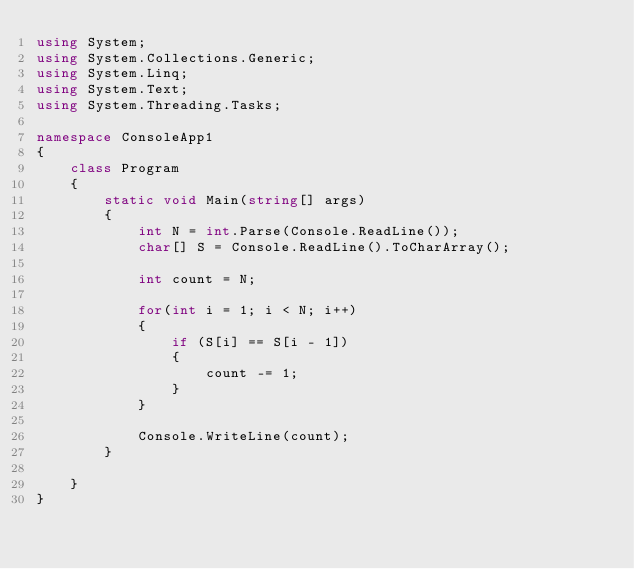Convert code to text. <code><loc_0><loc_0><loc_500><loc_500><_C#_>using System;
using System.Collections.Generic;
using System.Linq;
using System.Text;
using System.Threading.Tasks;

namespace ConsoleApp1
{
    class Program
    {
        static void Main(string[] args)
        {
            int N = int.Parse(Console.ReadLine());
            char[] S = Console.ReadLine().ToCharArray();

            int count = N;

            for(int i = 1; i < N; i++)
            {
                if (S[i] == S[i - 1])
                {
                    count -= 1;
                }
            }

            Console.WriteLine(count);
        }

    }
}</code> 